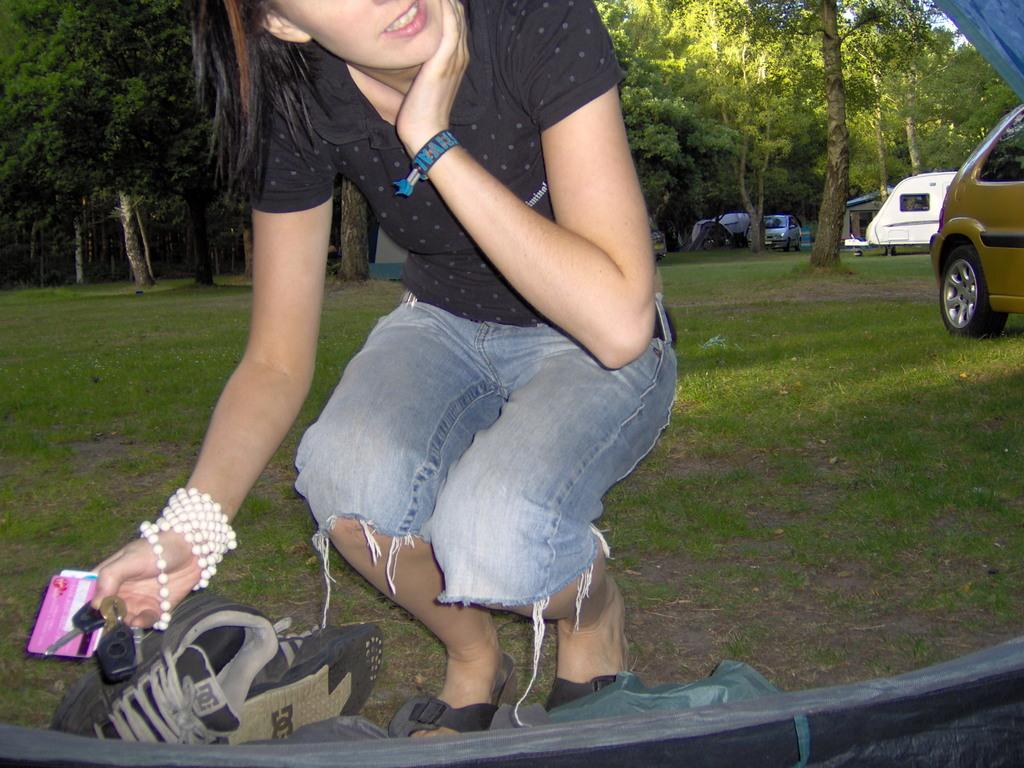Who is in the image? There is a woman in the image. What is the woman holding? The woman is holding cards. Can you describe any other objects in the image? There is a pair of shoes visible in the image, as well as grass, vehicles, and trees. What is located at the bottom of the image? There is an object at the bottom of the image. What type of pen is the woman using to make a payment in the image? There is no pen or payment activity present in the image. What color are the woman's lips in the image? The image does not provide information about the color of the woman's lips. 